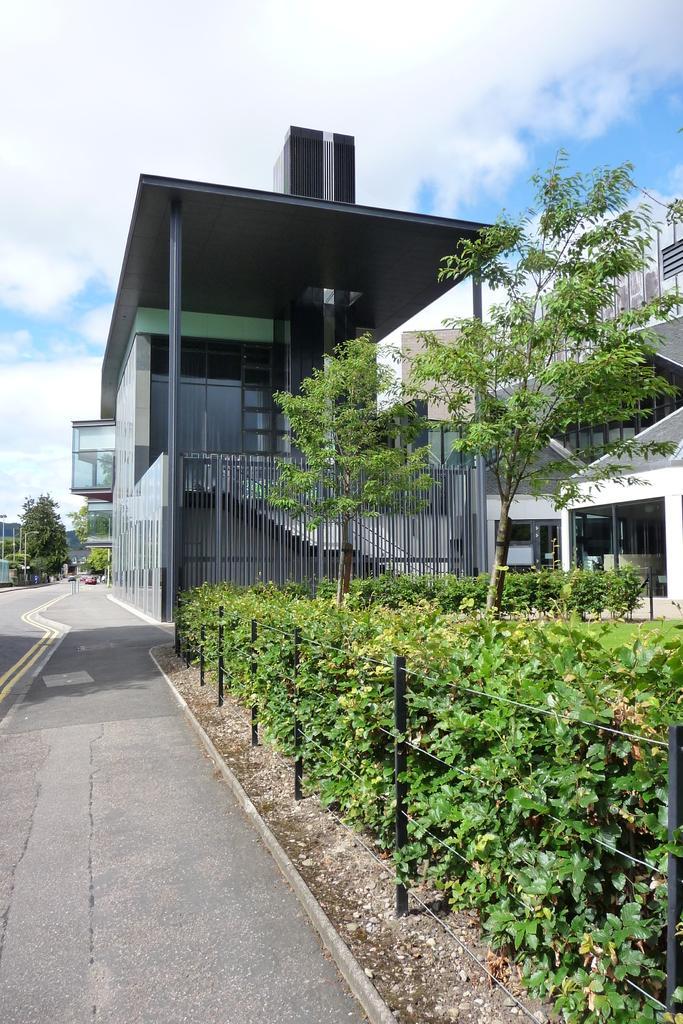How would you summarize this image in a sentence or two? In this picture I can see plants, trees, fence, buildings, road, and in the background there is sky. 